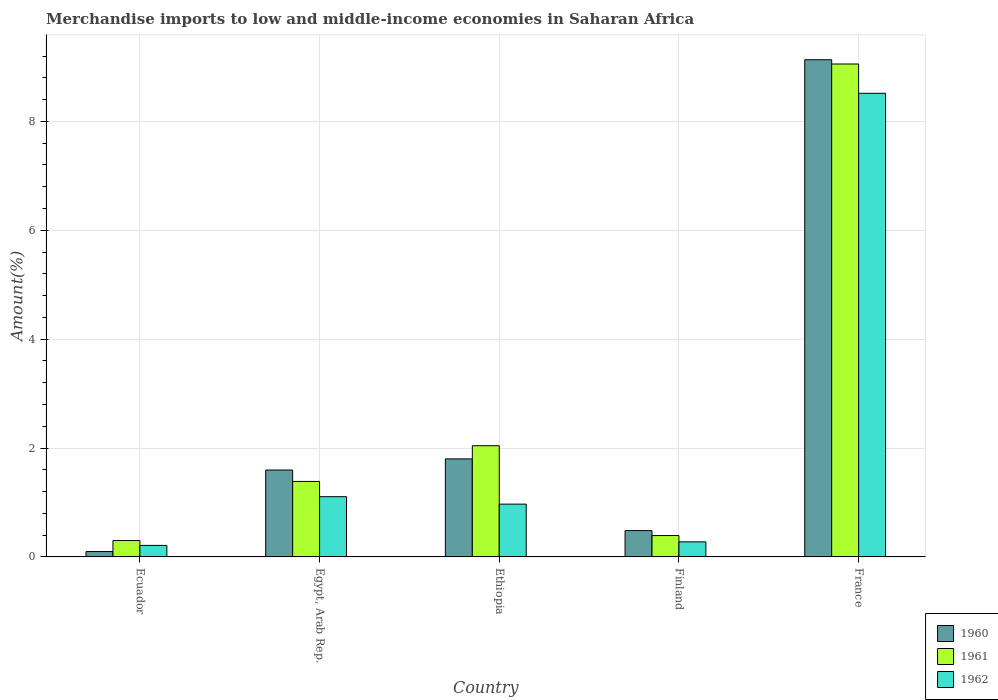How many groups of bars are there?
Your response must be concise. 5. Are the number of bars per tick equal to the number of legend labels?
Give a very brief answer. Yes. Are the number of bars on each tick of the X-axis equal?
Provide a short and direct response. Yes. How many bars are there on the 3rd tick from the left?
Offer a terse response. 3. What is the percentage of amount earned from merchandise imports in 1962 in Ethiopia?
Your answer should be very brief. 0.97. Across all countries, what is the maximum percentage of amount earned from merchandise imports in 1961?
Your response must be concise. 9.06. Across all countries, what is the minimum percentage of amount earned from merchandise imports in 1960?
Provide a short and direct response. 0.1. In which country was the percentage of amount earned from merchandise imports in 1962 minimum?
Keep it short and to the point. Ecuador. What is the total percentage of amount earned from merchandise imports in 1961 in the graph?
Make the answer very short. 13.18. What is the difference between the percentage of amount earned from merchandise imports in 1962 in Ethiopia and that in France?
Give a very brief answer. -7.55. What is the difference between the percentage of amount earned from merchandise imports in 1961 in Ethiopia and the percentage of amount earned from merchandise imports in 1962 in Finland?
Provide a short and direct response. 1.77. What is the average percentage of amount earned from merchandise imports in 1960 per country?
Offer a very short reply. 2.62. What is the difference between the percentage of amount earned from merchandise imports of/in 1961 and percentage of amount earned from merchandise imports of/in 1960 in France?
Offer a terse response. -0.08. What is the ratio of the percentage of amount earned from merchandise imports in 1960 in Ecuador to that in France?
Provide a short and direct response. 0.01. Is the percentage of amount earned from merchandise imports in 1962 in Ecuador less than that in Finland?
Offer a terse response. Yes. What is the difference between the highest and the second highest percentage of amount earned from merchandise imports in 1961?
Offer a terse response. 7.01. What is the difference between the highest and the lowest percentage of amount earned from merchandise imports in 1961?
Provide a short and direct response. 8.75. In how many countries, is the percentage of amount earned from merchandise imports in 1961 greater than the average percentage of amount earned from merchandise imports in 1961 taken over all countries?
Your response must be concise. 1. Is the sum of the percentage of amount earned from merchandise imports in 1960 in Ethiopia and France greater than the maximum percentage of amount earned from merchandise imports in 1962 across all countries?
Ensure brevity in your answer.  Yes. What does the 3rd bar from the left in Egypt, Arab Rep. represents?
Ensure brevity in your answer.  1962. Are all the bars in the graph horizontal?
Provide a short and direct response. No. What is the difference between two consecutive major ticks on the Y-axis?
Give a very brief answer. 2. Where does the legend appear in the graph?
Your answer should be compact. Bottom right. How many legend labels are there?
Your response must be concise. 3. How are the legend labels stacked?
Your answer should be compact. Vertical. What is the title of the graph?
Provide a short and direct response. Merchandise imports to low and middle-income economies in Saharan Africa. Does "1967" appear as one of the legend labels in the graph?
Ensure brevity in your answer.  No. What is the label or title of the X-axis?
Make the answer very short. Country. What is the label or title of the Y-axis?
Keep it short and to the point. Amount(%). What is the Amount(%) in 1960 in Ecuador?
Offer a terse response. 0.1. What is the Amount(%) in 1961 in Ecuador?
Ensure brevity in your answer.  0.3. What is the Amount(%) in 1962 in Ecuador?
Keep it short and to the point. 0.21. What is the Amount(%) in 1960 in Egypt, Arab Rep.?
Ensure brevity in your answer.  1.6. What is the Amount(%) in 1961 in Egypt, Arab Rep.?
Your answer should be very brief. 1.39. What is the Amount(%) of 1962 in Egypt, Arab Rep.?
Your response must be concise. 1.11. What is the Amount(%) of 1960 in Ethiopia?
Offer a very short reply. 1.8. What is the Amount(%) of 1961 in Ethiopia?
Keep it short and to the point. 2.04. What is the Amount(%) of 1962 in Ethiopia?
Offer a terse response. 0.97. What is the Amount(%) in 1960 in Finland?
Offer a very short reply. 0.48. What is the Amount(%) of 1961 in Finland?
Offer a terse response. 0.39. What is the Amount(%) of 1962 in Finland?
Offer a terse response. 0.28. What is the Amount(%) in 1960 in France?
Offer a very short reply. 9.13. What is the Amount(%) of 1961 in France?
Your answer should be very brief. 9.06. What is the Amount(%) in 1962 in France?
Make the answer very short. 8.52. Across all countries, what is the maximum Amount(%) of 1960?
Your response must be concise. 9.13. Across all countries, what is the maximum Amount(%) in 1961?
Give a very brief answer. 9.06. Across all countries, what is the maximum Amount(%) of 1962?
Offer a very short reply. 8.52. Across all countries, what is the minimum Amount(%) in 1960?
Keep it short and to the point. 0.1. Across all countries, what is the minimum Amount(%) in 1961?
Make the answer very short. 0.3. Across all countries, what is the minimum Amount(%) of 1962?
Your answer should be compact. 0.21. What is the total Amount(%) in 1960 in the graph?
Your answer should be compact. 13.11. What is the total Amount(%) in 1961 in the graph?
Provide a succinct answer. 13.18. What is the total Amount(%) of 1962 in the graph?
Provide a succinct answer. 11.08. What is the difference between the Amount(%) of 1960 in Ecuador and that in Egypt, Arab Rep.?
Keep it short and to the point. -1.5. What is the difference between the Amount(%) in 1961 in Ecuador and that in Egypt, Arab Rep.?
Offer a very short reply. -1.09. What is the difference between the Amount(%) of 1962 in Ecuador and that in Egypt, Arab Rep.?
Your response must be concise. -0.89. What is the difference between the Amount(%) in 1960 in Ecuador and that in Ethiopia?
Ensure brevity in your answer.  -1.7. What is the difference between the Amount(%) in 1961 in Ecuador and that in Ethiopia?
Give a very brief answer. -1.74. What is the difference between the Amount(%) in 1962 in Ecuador and that in Ethiopia?
Your answer should be very brief. -0.76. What is the difference between the Amount(%) in 1960 in Ecuador and that in Finland?
Offer a very short reply. -0.38. What is the difference between the Amount(%) in 1961 in Ecuador and that in Finland?
Keep it short and to the point. -0.09. What is the difference between the Amount(%) in 1962 in Ecuador and that in Finland?
Offer a terse response. -0.07. What is the difference between the Amount(%) of 1960 in Ecuador and that in France?
Ensure brevity in your answer.  -9.03. What is the difference between the Amount(%) of 1961 in Ecuador and that in France?
Keep it short and to the point. -8.75. What is the difference between the Amount(%) in 1962 in Ecuador and that in France?
Keep it short and to the point. -8.31. What is the difference between the Amount(%) of 1960 in Egypt, Arab Rep. and that in Ethiopia?
Make the answer very short. -0.2. What is the difference between the Amount(%) of 1961 in Egypt, Arab Rep. and that in Ethiopia?
Your response must be concise. -0.66. What is the difference between the Amount(%) in 1962 in Egypt, Arab Rep. and that in Ethiopia?
Keep it short and to the point. 0.14. What is the difference between the Amount(%) of 1960 in Egypt, Arab Rep. and that in Finland?
Keep it short and to the point. 1.11. What is the difference between the Amount(%) of 1962 in Egypt, Arab Rep. and that in Finland?
Keep it short and to the point. 0.83. What is the difference between the Amount(%) of 1960 in Egypt, Arab Rep. and that in France?
Offer a very short reply. -7.54. What is the difference between the Amount(%) of 1961 in Egypt, Arab Rep. and that in France?
Offer a very short reply. -7.67. What is the difference between the Amount(%) in 1962 in Egypt, Arab Rep. and that in France?
Your response must be concise. -7.41. What is the difference between the Amount(%) in 1960 in Ethiopia and that in Finland?
Your answer should be compact. 1.32. What is the difference between the Amount(%) in 1961 in Ethiopia and that in Finland?
Ensure brevity in your answer.  1.65. What is the difference between the Amount(%) of 1962 in Ethiopia and that in Finland?
Make the answer very short. 0.69. What is the difference between the Amount(%) of 1960 in Ethiopia and that in France?
Offer a very short reply. -7.33. What is the difference between the Amount(%) of 1961 in Ethiopia and that in France?
Make the answer very short. -7.01. What is the difference between the Amount(%) of 1962 in Ethiopia and that in France?
Provide a short and direct response. -7.55. What is the difference between the Amount(%) in 1960 in Finland and that in France?
Offer a very short reply. -8.65. What is the difference between the Amount(%) in 1961 in Finland and that in France?
Your response must be concise. -8.66. What is the difference between the Amount(%) of 1962 in Finland and that in France?
Give a very brief answer. -8.24. What is the difference between the Amount(%) in 1960 in Ecuador and the Amount(%) in 1961 in Egypt, Arab Rep.?
Give a very brief answer. -1.29. What is the difference between the Amount(%) of 1960 in Ecuador and the Amount(%) of 1962 in Egypt, Arab Rep.?
Your answer should be very brief. -1.01. What is the difference between the Amount(%) of 1961 in Ecuador and the Amount(%) of 1962 in Egypt, Arab Rep.?
Give a very brief answer. -0.81. What is the difference between the Amount(%) in 1960 in Ecuador and the Amount(%) in 1961 in Ethiopia?
Ensure brevity in your answer.  -1.94. What is the difference between the Amount(%) in 1960 in Ecuador and the Amount(%) in 1962 in Ethiopia?
Offer a terse response. -0.87. What is the difference between the Amount(%) in 1961 in Ecuador and the Amount(%) in 1962 in Ethiopia?
Your answer should be compact. -0.67. What is the difference between the Amount(%) in 1960 in Ecuador and the Amount(%) in 1961 in Finland?
Offer a terse response. -0.29. What is the difference between the Amount(%) in 1960 in Ecuador and the Amount(%) in 1962 in Finland?
Provide a succinct answer. -0.18. What is the difference between the Amount(%) of 1961 in Ecuador and the Amount(%) of 1962 in Finland?
Your answer should be very brief. 0.02. What is the difference between the Amount(%) of 1960 in Ecuador and the Amount(%) of 1961 in France?
Give a very brief answer. -8.96. What is the difference between the Amount(%) in 1960 in Ecuador and the Amount(%) in 1962 in France?
Ensure brevity in your answer.  -8.42. What is the difference between the Amount(%) in 1961 in Ecuador and the Amount(%) in 1962 in France?
Ensure brevity in your answer.  -8.22. What is the difference between the Amount(%) of 1960 in Egypt, Arab Rep. and the Amount(%) of 1961 in Ethiopia?
Make the answer very short. -0.45. What is the difference between the Amount(%) of 1960 in Egypt, Arab Rep. and the Amount(%) of 1962 in Ethiopia?
Provide a short and direct response. 0.63. What is the difference between the Amount(%) of 1961 in Egypt, Arab Rep. and the Amount(%) of 1962 in Ethiopia?
Give a very brief answer. 0.42. What is the difference between the Amount(%) in 1960 in Egypt, Arab Rep. and the Amount(%) in 1961 in Finland?
Keep it short and to the point. 1.2. What is the difference between the Amount(%) in 1960 in Egypt, Arab Rep. and the Amount(%) in 1962 in Finland?
Keep it short and to the point. 1.32. What is the difference between the Amount(%) of 1961 in Egypt, Arab Rep. and the Amount(%) of 1962 in Finland?
Keep it short and to the point. 1.11. What is the difference between the Amount(%) of 1960 in Egypt, Arab Rep. and the Amount(%) of 1961 in France?
Ensure brevity in your answer.  -7.46. What is the difference between the Amount(%) of 1960 in Egypt, Arab Rep. and the Amount(%) of 1962 in France?
Your answer should be compact. -6.92. What is the difference between the Amount(%) in 1961 in Egypt, Arab Rep. and the Amount(%) in 1962 in France?
Offer a very short reply. -7.13. What is the difference between the Amount(%) in 1960 in Ethiopia and the Amount(%) in 1961 in Finland?
Your answer should be very brief. 1.41. What is the difference between the Amount(%) in 1960 in Ethiopia and the Amount(%) in 1962 in Finland?
Give a very brief answer. 1.52. What is the difference between the Amount(%) in 1961 in Ethiopia and the Amount(%) in 1962 in Finland?
Offer a very short reply. 1.77. What is the difference between the Amount(%) in 1960 in Ethiopia and the Amount(%) in 1961 in France?
Offer a terse response. -7.25. What is the difference between the Amount(%) in 1960 in Ethiopia and the Amount(%) in 1962 in France?
Offer a terse response. -6.72. What is the difference between the Amount(%) in 1961 in Ethiopia and the Amount(%) in 1962 in France?
Your response must be concise. -6.47. What is the difference between the Amount(%) of 1960 in Finland and the Amount(%) of 1961 in France?
Provide a succinct answer. -8.57. What is the difference between the Amount(%) of 1960 in Finland and the Amount(%) of 1962 in France?
Your response must be concise. -8.03. What is the difference between the Amount(%) of 1961 in Finland and the Amount(%) of 1962 in France?
Give a very brief answer. -8.12. What is the average Amount(%) of 1960 per country?
Offer a very short reply. 2.62. What is the average Amount(%) in 1961 per country?
Provide a short and direct response. 2.64. What is the average Amount(%) of 1962 per country?
Your response must be concise. 2.22. What is the difference between the Amount(%) in 1960 and Amount(%) in 1961 in Ecuador?
Provide a succinct answer. -0.2. What is the difference between the Amount(%) in 1960 and Amount(%) in 1962 in Ecuador?
Ensure brevity in your answer.  -0.11. What is the difference between the Amount(%) of 1961 and Amount(%) of 1962 in Ecuador?
Make the answer very short. 0.09. What is the difference between the Amount(%) of 1960 and Amount(%) of 1961 in Egypt, Arab Rep.?
Offer a terse response. 0.21. What is the difference between the Amount(%) in 1960 and Amount(%) in 1962 in Egypt, Arab Rep.?
Provide a short and direct response. 0.49. What is the difference between the Amount(%) of 1961 and Amount(%) of 1962 in Egypt, Arab Rep.?
Offer a terse response. 0.28. What is the difference between the Amount(%) in 1960 and Amount(%) in 1961 in Ethiopia?
Your answer should be very brief. -0.24. What is the difference between the Amount(%) in 1960 and Amount(%) in 1962 in Ethiopia?
Provide a short and direct response. 0.83. What is the difference between the Amount(%) in 1961 and Amount(%) in 1962 in Ethiopia?
Your answer should be very brief. 1.07. What is the difference between the Amount(%) in 1960 and Amount(%) in 1961 in Finland?
Your answer should be compact. 0.09. What is the difference between the Amount(%) in 1960 and Amount(%) in 1962 in Finland?
Provide a succinct answer. 0.21. What is the difference between the Amount(%) in 1961 and Amount(%) in 1962 in Finland?
Give a very brief answer. 0.12. What is the difference between the Amount(%) in 1960 and Amount(%) in 1961 in France?
Provide a short and direct response. 0.08. What is the difference between the Amount(%) in 1960 and Amount(%) in 1962 in France?
Provide a succinct answer. 0.62. What is the difference between the Amount(%) of 1961 and Amount(%) of 1962 in France?
Ensure brevity in your answer.  0.54. What is the ratio of the Amount(%) of 1960 in Ecuador to that in Egypt, Arab Rep.?
Offer a very short reply. 0.06. What is the ratio of the Amount(%) in 1961 in Ecuador to that in Egypt, Arab Rep.?
Keep it short and to the point. 0.22. What is the ratio of the Amount(%) of 1962 in Ecuador to that in Egypt, Arab Rep.?
Give a very brief answer. 0.19. What is the ratio of the Amount(%) in 1960 in Ecuador to that in Ethiopia?
Make the answer very short. 0.06. What is the ratio of the Amount(%) of 1961 in Ecuador to that in Ethiopia?
Provide a short and direct response. 0.15. What is the ratio of the Amount(%) of 1962 in Ecuador to that in Ethiopia?
Keep it short and to the point. 0.22. What is the ratio of the Amount(%) of 1960 in Ecuador to that in Finland?
Give a very brief answer. 0.2. What is the ratio of the Amount(%) of 1961 in Ecuador to that in Finland?
Ensure brevity in your answer.  0.77. What is the ratio of the Amount(%) of 1962 in Ecuador to that in Finland?
Make the answer very short. 0.77. What is the ratio of the Amount(%) of 1960 in Ecuador to that in France?
Offer a very short reply. 0.01. What is the ratio of the Amount(%) in 1961 in Ecuador to that in France?
Your answer should be compact. 0.03. What is the ratio of the Amount(%) of 1962 in Ecuador to that in France?
Offer a very short reply. 0.02. What is the ratio of the Amount(%) of 1960 in Egypt, Arab Rep. to that in Ethiopia?
Give a very brief answer. 0.89. What is the ratio of the Amount(%) of 1961 in Egypt, Arab Rep. to that in Ethiopia?
Give a very brief answer. 0.68. What is the ratio of the Amount(%) of 1962 in Egypt, Arab Rep. to that in Ethiopia?
Offer a terse response. 1.14. What is the ratio of the Amount(%) of 1960 in Egypt, Arab Rep. to that in Finland?
Ensure brevity in your answer.  3.3. What is the ratio of the Amount(%) in 1961 in Egypt, Arab Rep. to that in Finland?
Provide a short and direct response. 3.53. What is the ratio of the Amount(%) in 1962 in Egypt, Arab Rep. to that in Finland?
Your answer should be very brief. 4. What is the ratio of the Amount(%) of 1960 in Egypt, Arab Rep. to that in France?
Provide a short and direct response. 0.17. What is the ratio of the Amount(%) of 1961 in Egypt, Arab Rep. to that in France?
Your answer should be very brief. 0.15. What is the ratio of the Amount(%) in 1962 in Egypt, Arab Rep. to that in France?
Provide a succinct answer. 0.13. What is the ratio of the Amount(%) of 1960 in Ethiopia to that in Finland?
Keep it short and to the point. 3.72. What is the ratio of the Amount(%) in 1961 in Ethiopia to that in Finland?
Your response must be concise. 5.2. What is the ratio of the Amount(%) of 1962 in Ethiopia to that in Finland?
Give a very brief answer. 3.5. What is the ratio of the Amount(%) in 1960 in Ethiopia to that in France?
Your answer should be compact. 0.2. What is the ratio of the Amount(%) in 1961 in Ethiopia to that in France?
Give a very brief answer. 0.23. What is the ratio of the Amount(%) of 1962 in Ethiopia to that in France?
Your response must be concise. 0.11. What is the ratio of the Amount(%) of 1960 in Finland to that in France?
Offer a terse response. 0.05. What is the ratio of the Amount(%) in 1961 in Finland to that in France?
Offer a terse response. 0.04. What is the ratio of the Amount(%) in 1962 in Finland to that in France?
Provide a succinct answer. 0.03. What is the difference between the highest and the second highest Amount(%) of 1960?
Offer a very short reply. 7.33. What is the difference between the highest and the second highest Amount(%) in 1961?
Give a very brief answer. 7.01. What is the difference between the highest and the second highest Amount(%) in 1962?
Your answer should be very brief. 7.41. What is the difference between the highest and the lowest Amount(%) in 1960?
Offer a terse response. 9.03. What is the difference between the highest and the lowest Amount(%) in 1961?
Provide a short and direct response. 8.75. What is the difference between the highest and the lowest Amount(%) of 1962?
Your response must be concise. 8.31. 